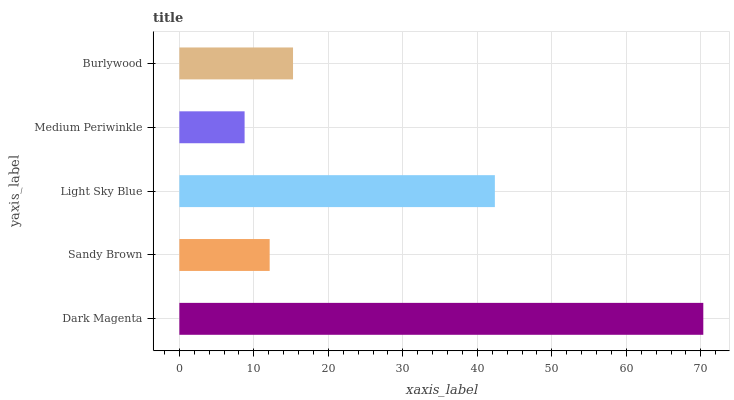Is Medium Periwinkle the minimum?
Answer yes or no. Yes. Is Dark Magenta the maximum?
Answer yes or no. Yes. Is Sandy Brown the minimum?
Answer yes or no. No. Is Sandy Brown the maximum?
Answer yes or no. No. Is Dark Magenta greater than Sandy Brown?
Answer yes or no. Yes. Is Sandy Brown less than Dark Magenta?
Answer yes or no. Yes. Is Sandy Brown greater than Dark Magenta?
Answer yes or no. No. Is Dark Magenta less than Sandy Brown?
Answer yes or no. No. Is Burlywood the high median?
Answer yes or no. Yes. Is Burlywood the low median?
Answer yes or no. Yes. Is Medium Periwinkle the high median?
Answer yes or no. No. Is Light Sky Blue the low median?
Answer yes or no. No. 